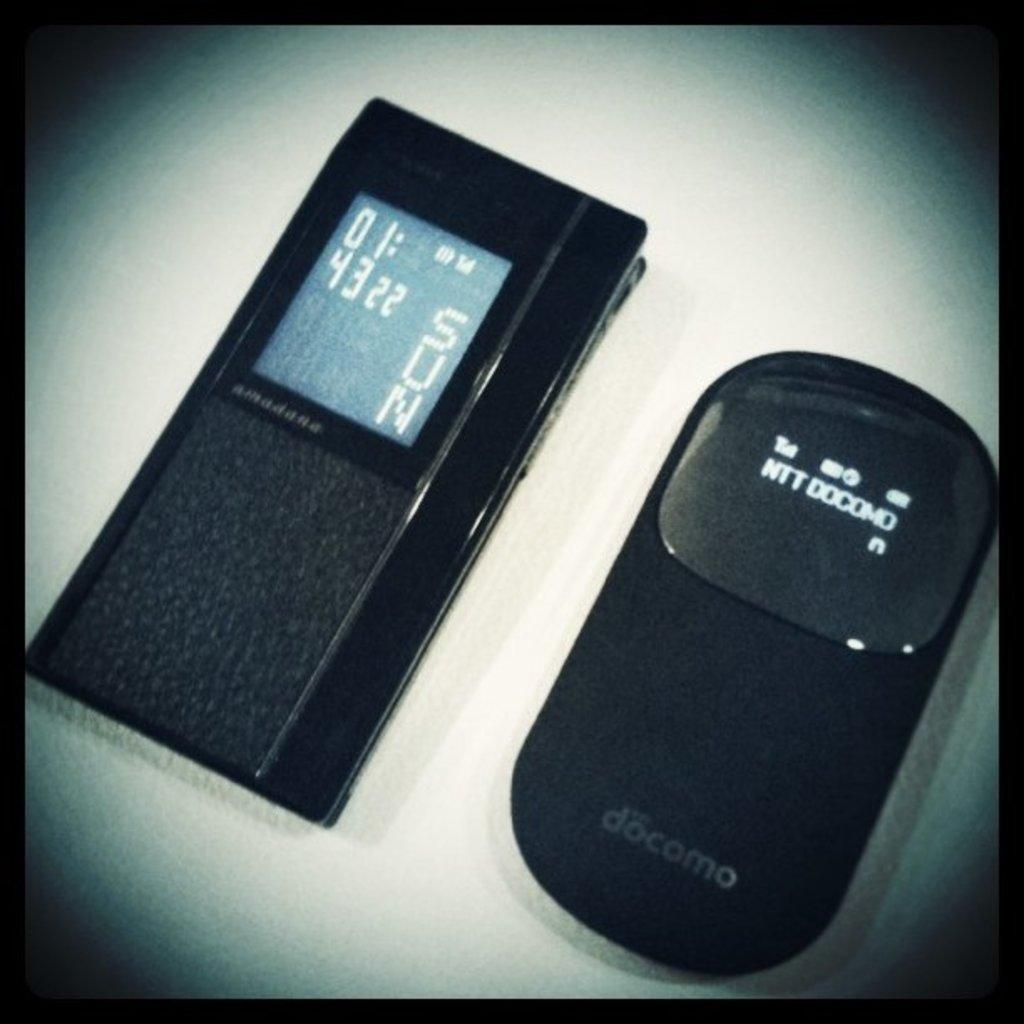Provide a one-sentence caption for the provided image. Two electronic devices with one saying it is a sunday and 43 degrees. 